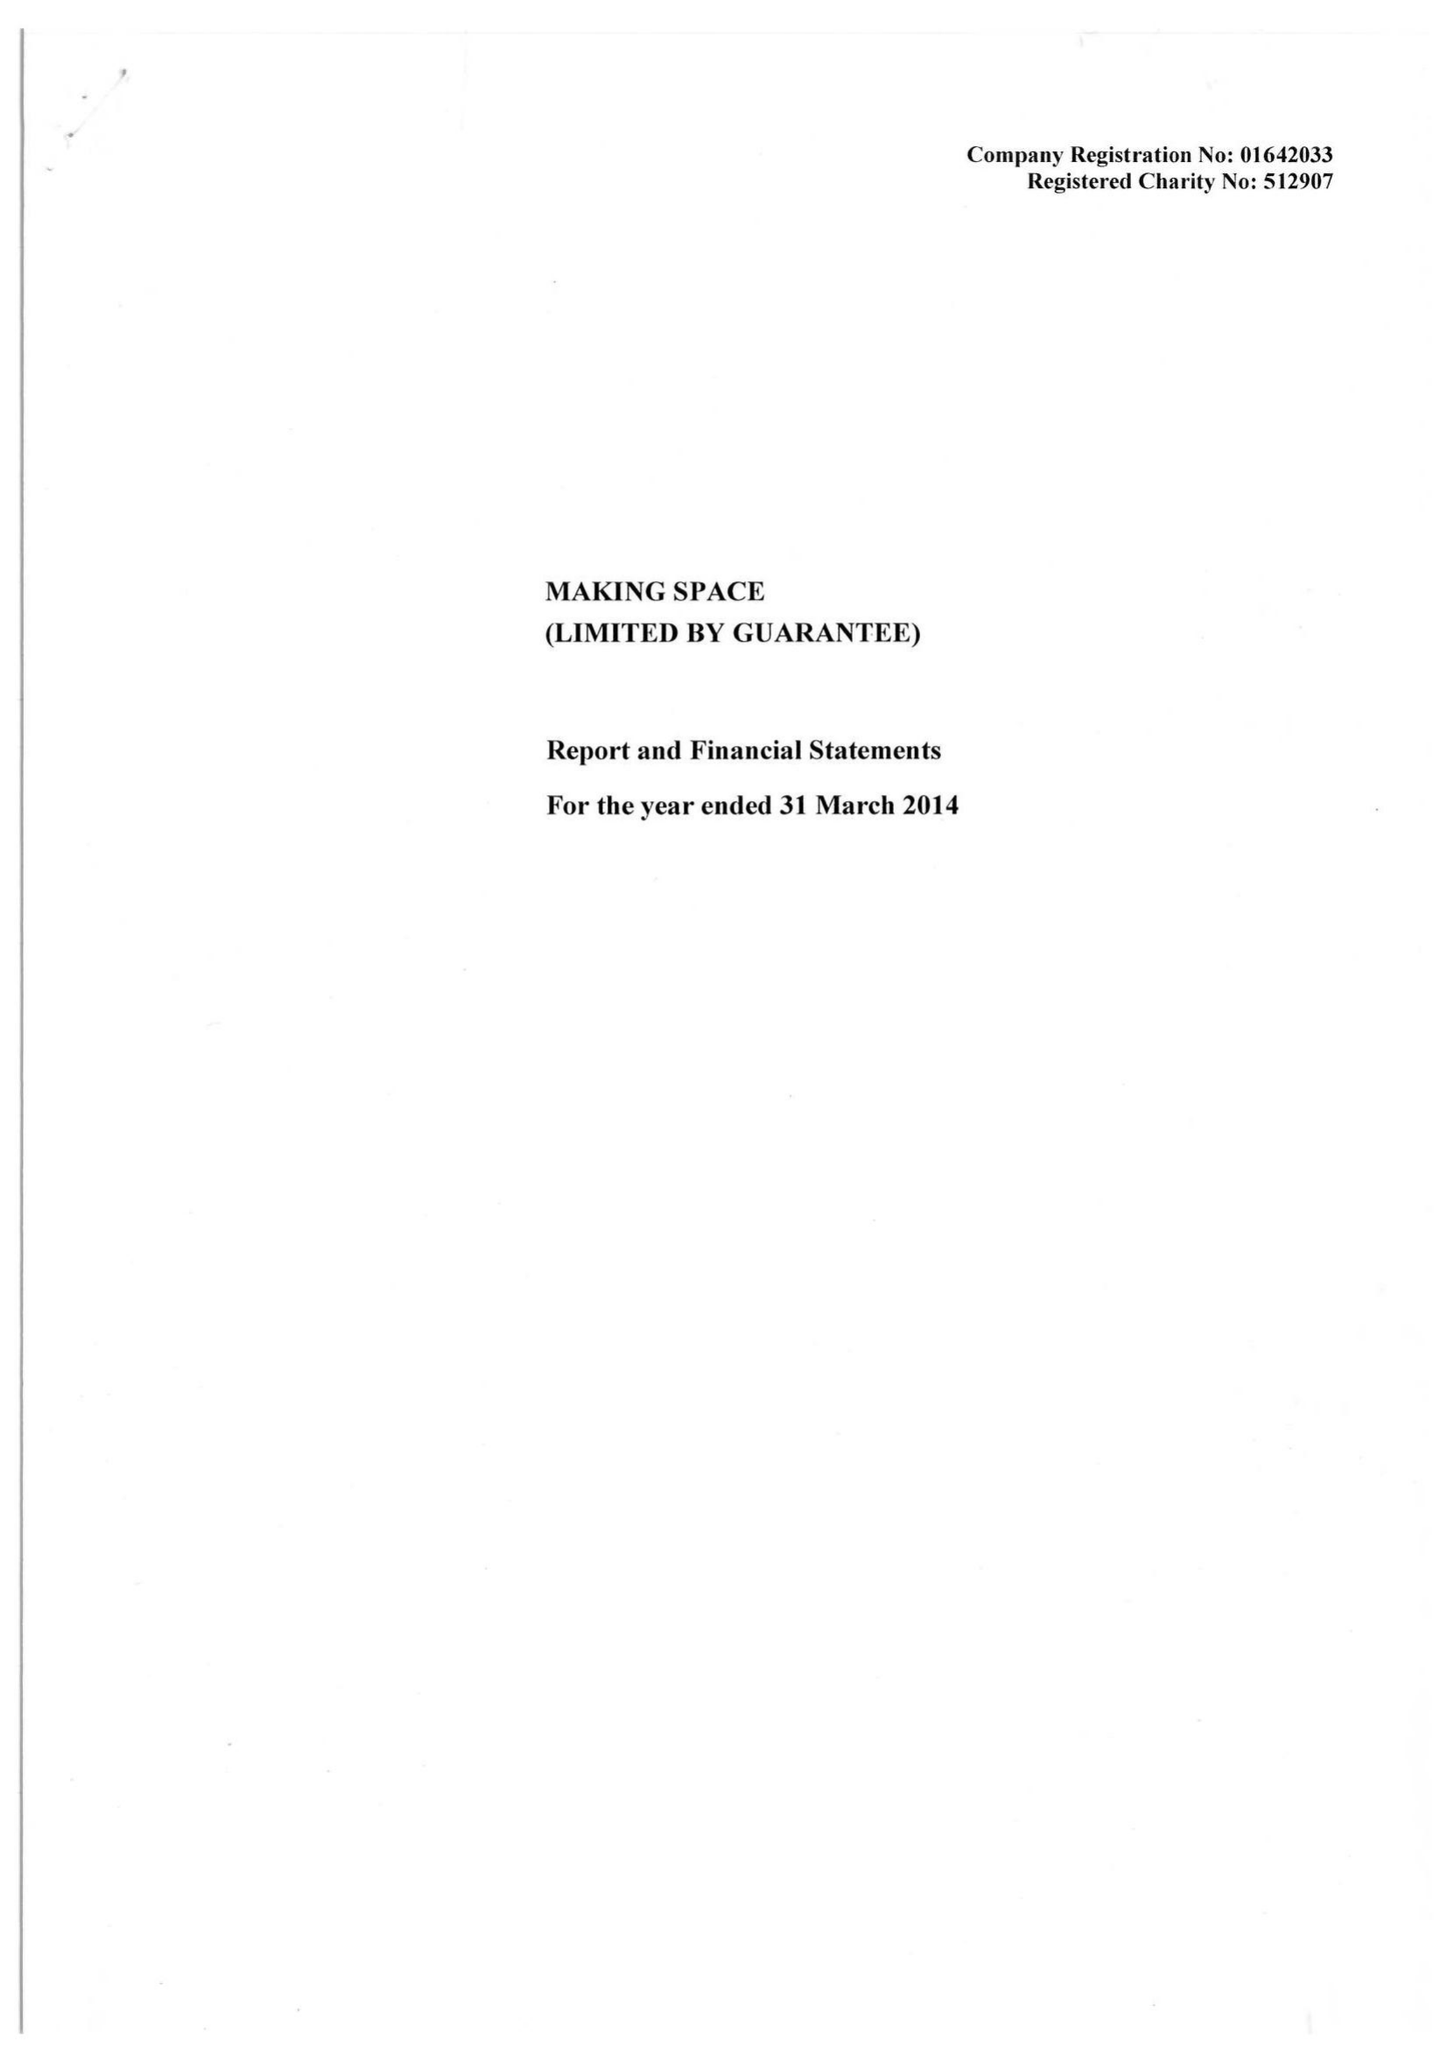What is the value for the charity_name?
Answer the question using a single word or phrase. Making Space 